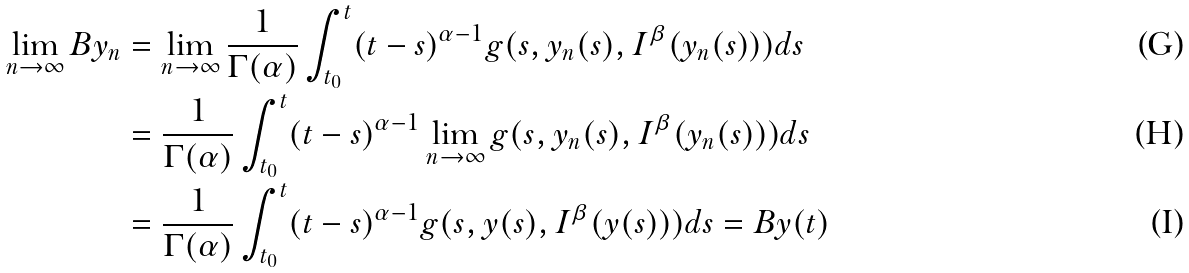Convert formula to latex. <formula><loc_0><loc_0><loc_500><loc_500>\lim _ { n \rightarrow \infty } B y _ { n } & = \lim _ { n \rightarrow \infty } \frac { 1 } { \Gamma ( \alpha ) } \int _ { t _ { 0 } } ^ { t } ( t - s ) ^ { \alpha - 1 } g ( s , y _ { n } ( s ) , I ^ { \beta } ( y _ { n } ( s ) ) ) d s \\ & = \frac { 1 } { \Gamma ( \alpha ) } \int _ { t _ { 0 } } ^ { t } ( t - s ) ^ { \alpha - 1 } \lim _ { n \rightarrow \infty } g ( s , y _ { n } ( s ) , I ^ { \beta } ( y _ { n } ( s ) ) ) d s \\ & = \frac { 1 } { \Gamma ( \alpha ) } \int _ { t _ { 0 } } ^ { t } ( t - s ) ^ { \alpha - 1 } g ( s , y ( s ) , I ^ { \beta } ( y ( s ) ) ) d s = B y ( t )</formula> 